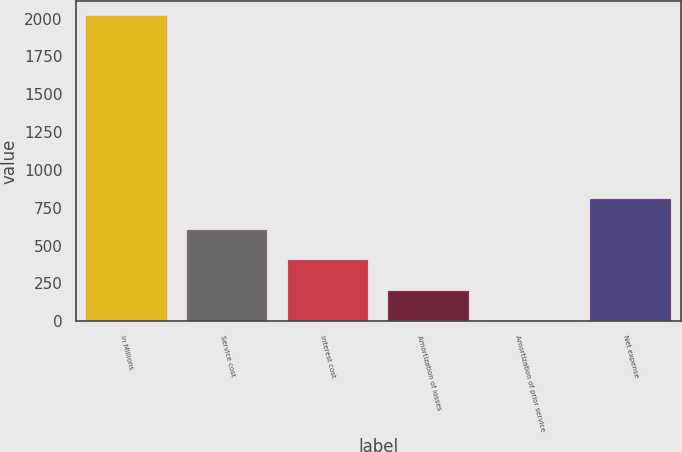Convert chart to OTSL. <chart><loc_0><loc_0><loc_500><loc_500><bar_chart><fcel>In Millions<fcel>Service cost<fcel>Interest cost<fcel>Amortization of losses<fcel>Amortization of prior service<fcel>Net expense<nl><fcel>2018<fcel>605.82<fcel>404.08<fcel>202.34<fcel>0.6<fcel>807.56<nl></chart> 